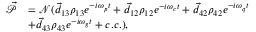<formula> <loc_0><loc_0><loc_500><loc_500>\begin{array} { r l } { \vec { \mathcal { P } } } & { = \mathcal { N } ( \vec { d } _ { 1 3 } \rho _ { 1 3 } e ^ { - i \omega _ { p } t } + \vec { d } _ { 1 2 } \rho _ { 1 2 } e ^ { - i \omega _ { c } t } + \vec { d } _ { 4 2 } \rho _ { 4 2 } e ^ { - i \omega _ { q } t } } \\ & { + \vec { d } _ { 4 3 } \rho _ { 4 3 } e ^ { - i \omega _ { g } t } + c . c . ) , } \end{array}</formula> 